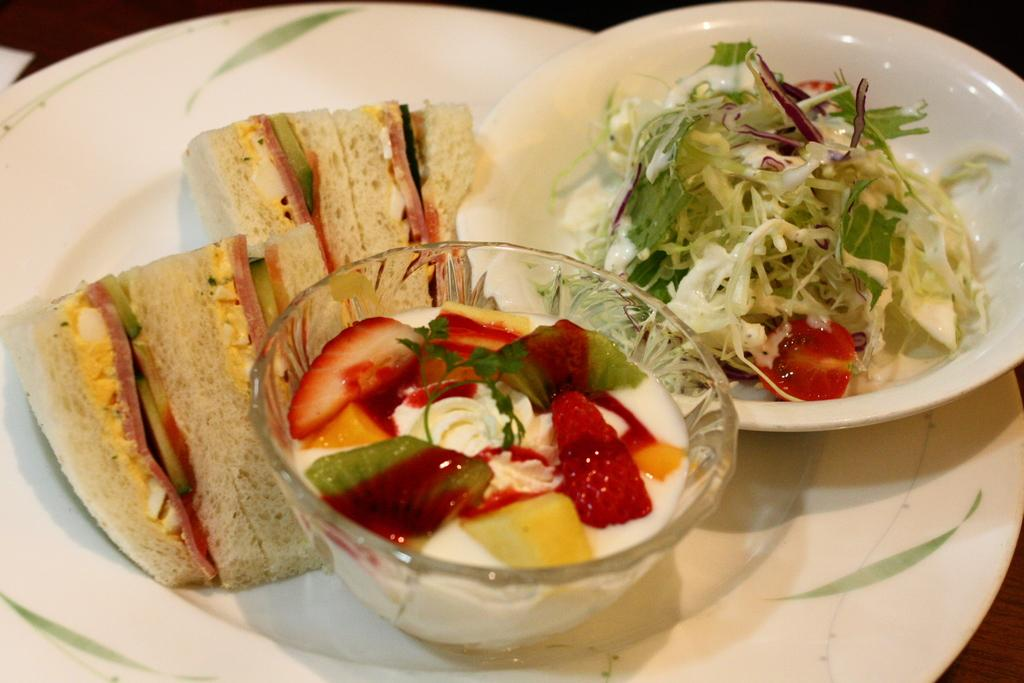What is present on the plates in the image? There is food in the plates in the image. Can you describe any other dish or container in the image? Yes, there is a bowl in the image. What type of collar can be seen on the food in the image? There is no collar present on the food in the image. 